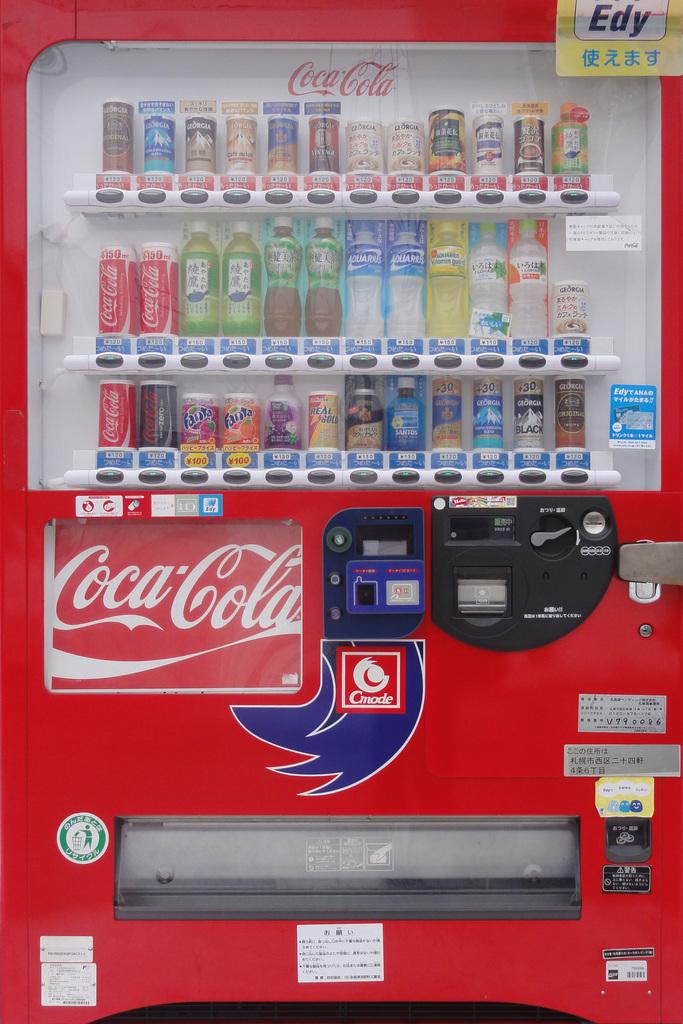What brand is advertised on the machine?
Offer a very short reply. Coca cola. 